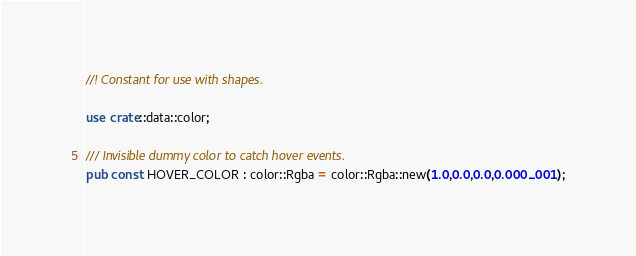<code> <loc_0><loc_0><loc_500><loc_500><_Rust_>//! Constant for use with shapes.

use crate::data::color;

/// Invisible dummy color to catch hover events.
pub const HOVER_COLOR : color::Rgba = color::Rgba::new(1.0,0.0,0.0,0.000_001);
</code> 